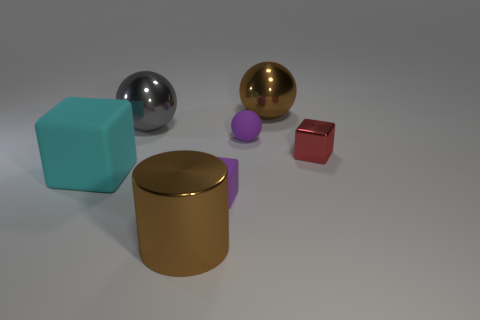What are the textures of the objects in the image? The image shows objects with varying textures. The cylinder and the two spheres have smooth and shiny surfaces, indicative of a metallic texture. The cube, on the other hand, appears to have a matte, solid texture, while the smaller cube has a similar matte finish but is less visible, likely due to its size or the lighting. 